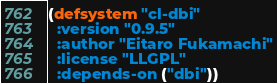Convert code to text. <code><loc_0><loc_0><loc_500><loc_500><_Lisp_>(defsystem "cl-dbi"
  :version "0.9.5"
  :author "Eitaro Fukamachi"
  :license "LLGPL"
  :depends-on ("dbi"))
</code> 